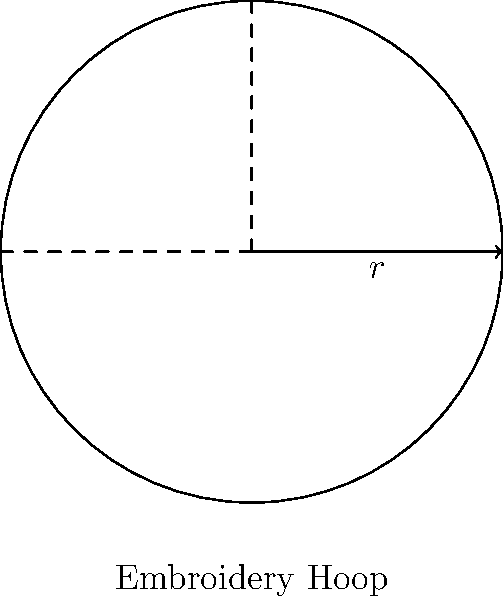As a sales representative for our sewing machine company, you're demonstrating a circular embroidery hoop attachment. The hoop has a radius of 5 inches. Calculate the area of fabric that can be embroidered within this hoop. Round your answer to two decimal places. To calculate the area of fabric that can be embroidered within the circular hoop, we need to use the formula for the area of a circle:

$$A = \pi r^2$$

Where:
$A$ = area
$\pi$ ≈ 3.14159
$r$ = radius

Given:
$r = 5$ inches

Step 1: Substitute the values into the formula:
$$A = \pi (5)^2$$

Step 2: Calculate the square of the radius:
$$A = \pi (25)$$

Step 3: Multiply by π:
$$A = 3.14159 \times 25 = 78.53975$$

Step 4: Round to two decimal places:
$$A ≈ 78.54 \text{ square inches}$$
Answer: 78.54 square inches 